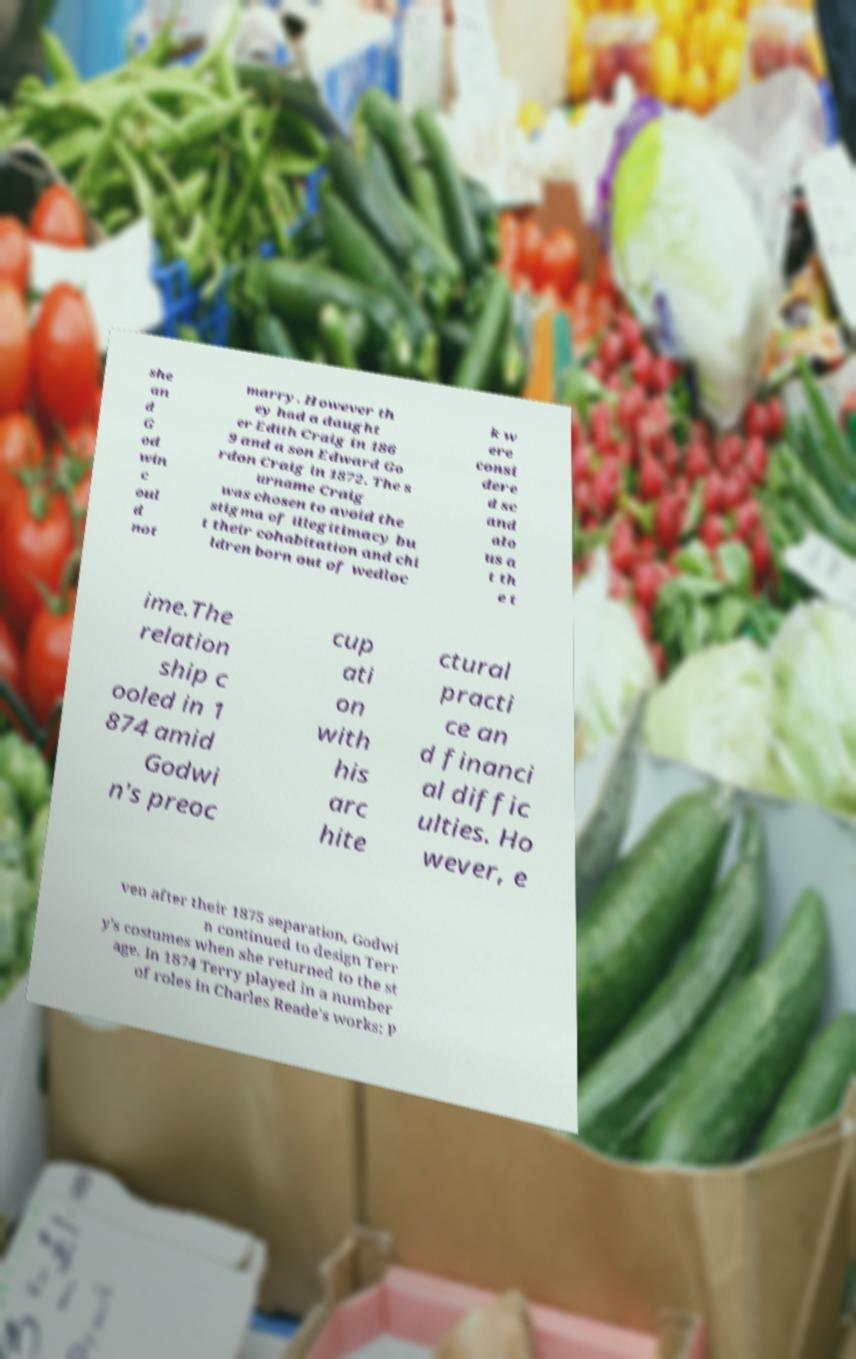I need the written content from this picture converted into text. Can you do that? she an d G od win c oul d not marry. However th ey had a daught er Edith Craig in 186 9 and a son Edward Go rdon Craig in 1872. The s urname Craig was chosen to avoid the stigma of illegitimacy bu t their cohabitation and chi ldren born out of wedloc k w ere consi dere d sc and alo us a t th e t ime.The relation ship c ooled in 1 874 amid Godwi n's preoc cup ati on with his arc hite ctural practi ce an d financi al diffic ulties. Ho wever, e ven after their 1875 separation, Godwi n continued to design Terr y's costumes when she returned to the st age. In 1874 Terry played in a number of roles in Charles Reade's works: P 